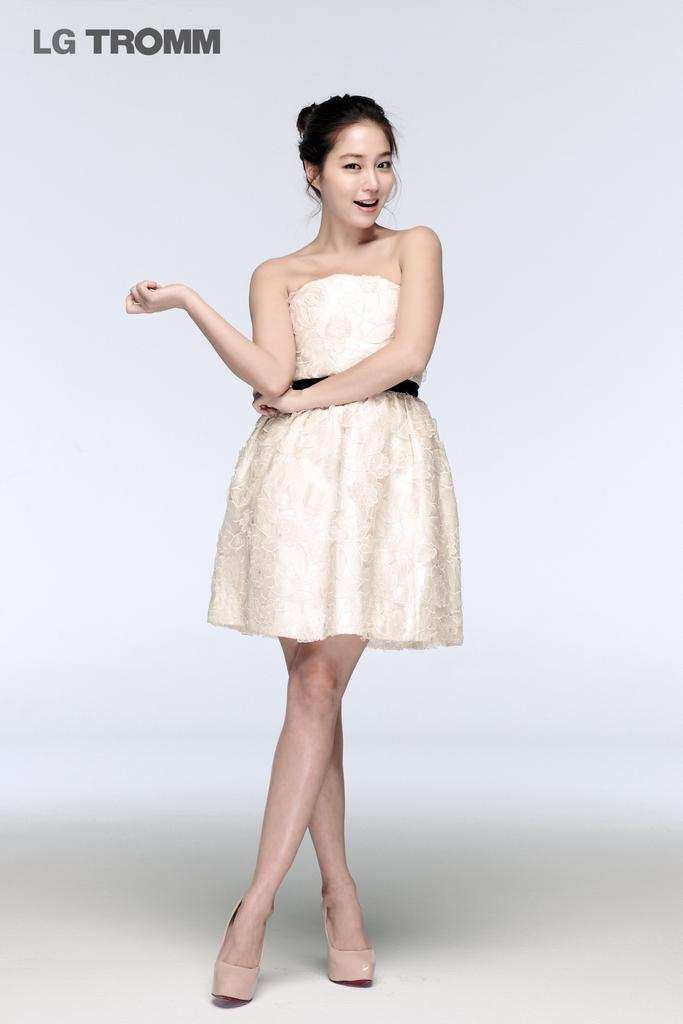What is the main subject of the image? There is a woman in the image. What is the woman doing in the image? The woman is standing on the floor. How does the woman appear in the image? The woman has a pretty smile on her face. What type of underwear is the woman wearing in the image? There is no information about the woman's underwear in the image, so it cannot be determined. 